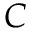Convert formula to latex. <formula><loc_0><loc_0><loc_500><loc_500>C</formula> 